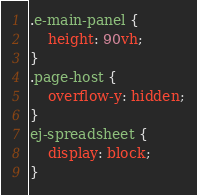<code> <loc_0><loc_0><loc_500><loc_500><_CSS_>.e-main-panel {
	height: 90vh;
}
.page-host {
    overflow-y: hidden;
}
ej-spreadsheet {
	display: block;
}</code> 